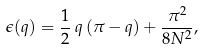Convert formula to latex. <formula><loc_0><loc_0><loc_500><loc_500>\epsilon ( q ) = \frac { 1 } { 2 } \, { q \, ( \pi - q ) } + \frac { \pi ^ { 2 } } { 8 N ^ { 2 } } ,</formula> 